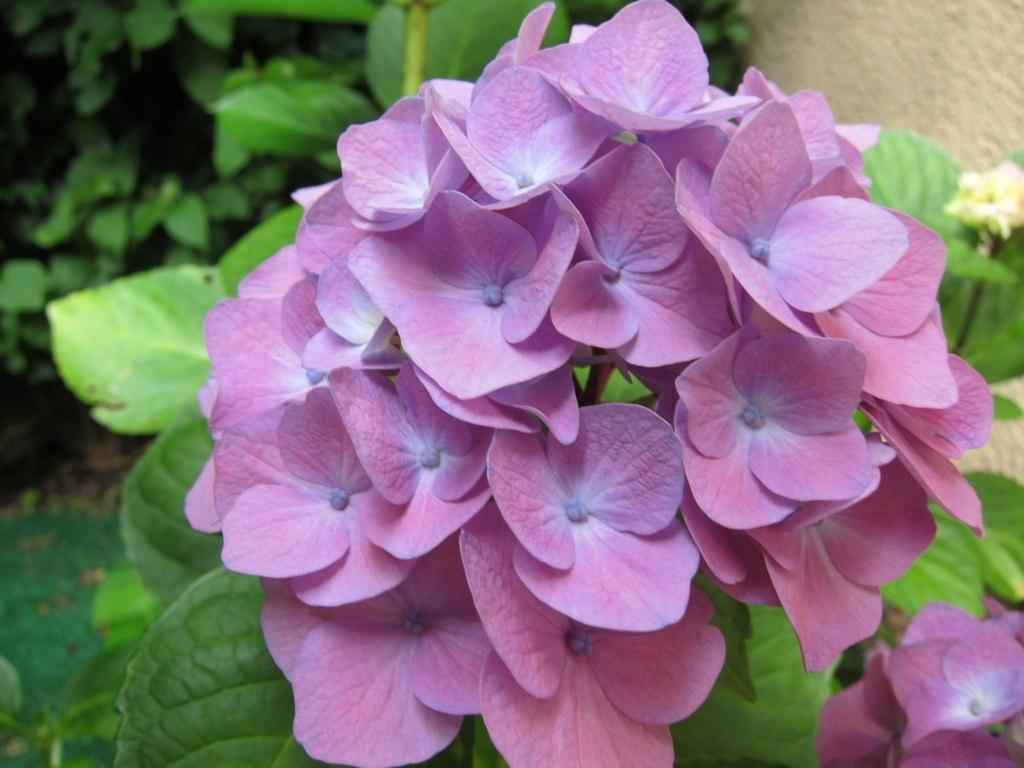Describe this image in one or two sentences. In the foreground of the picture, there are flowers to a plant. In the background, there are plants and a wall. 